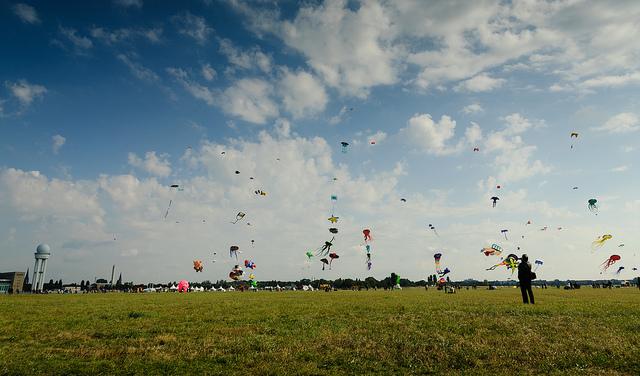What type of grass is that?
Be succinct. Green. Does there appear to be more than 4 kites in the air?
Short answer required. Yes. Is this picture black and white or color?
Write a very short answer. Color. What is the person doing?
Concise answer only. Flying kite. Is the sky clear?
Keep it brief. No. Is the lawn well mowed?
Short answer required. Yes. How many people are visible in this image?
Answer briefly. 1. Are there any people?
Write a very short answer. Yes. Is there a lot of traffic?
Be succinct. No. Is it raining?
Be succinct. No. Is the sky blue with clouds?
Be succinct. Yes. Is this a wire fence?
Answer briefly. No. Does the landscape appear to be manicured or overgrown?
Short answer required. Manicured. Is there a school in the background?
Keep it brief. No. Is that a butterfly in the sky?
Answer briefly. No. How many kites are flying?
Be succinct. 50. The cloud in the sky sort of shape a heart?
Keep it brief. No. Are all the birds in the air?
Quick response, please. No. Does the clouds above bring rain?
Answer briefly. No. What is cast?
Concise answer only. Kites. Is this a lonely area?
Give a very brief answer. No. 